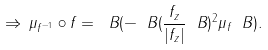<formula> <loc_0><loc_0><loc_500><loc_500>\Rightarrow \, \mu _ { f ^ { - 1 } } \circ f = \ B ( - \ B ( \frac { f _ { z } } { | f _ { z } | } \ B ) ^ { 2 } \mu { _ { f } } \ B ) .</formula> 